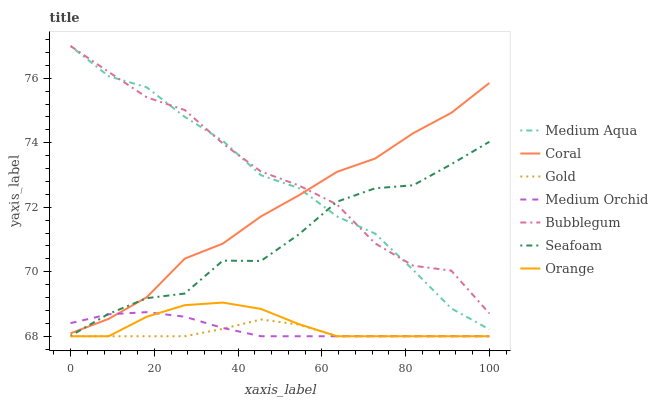Does Gold have the minimum area under the curve?
Answer yes or no. Yes. Does Bubblegum have the maximum area under the curve?
Answer yes or no. Yes. Does Coral have the minimum area under the curve?
Answer yes or no. No. Does Coral have the maximum area under the curve?
Answer yes or no. No. Is Medium Orchid the smoothest?
Answer yes or no. Yes. Is Seafoam the roughest?
Answer yes or no. Yes. Is Coral the smoothest?
Answer yes or no. No. Is Coral the roughest?
Answer yes or no. No. Does Gold have the lowest value?
Answer yes or no. Yes. Does Coral have the lowest value?
Answer yes or no. No. Does Medium Aqua have the highest value?
Answer yes or no. Yes. Does Coral have the highest value?
Answer yes or no. No. Is Medium Orchid less than Bubblegum?
Answer yes or no. Yes. Is Medium Aqua greater than Orange?
Answer yes or no. Yes. Does Coral intersect Bubblegum?
Answer yes or no. Yes. Is Coral less than Bubblegum?
Answer yes or no. No. Is Coral greater than Bubblegum?
Answer yes or no. No. Does Medium Orchid intersect Bubblegum?
Answer yes or no. No. 